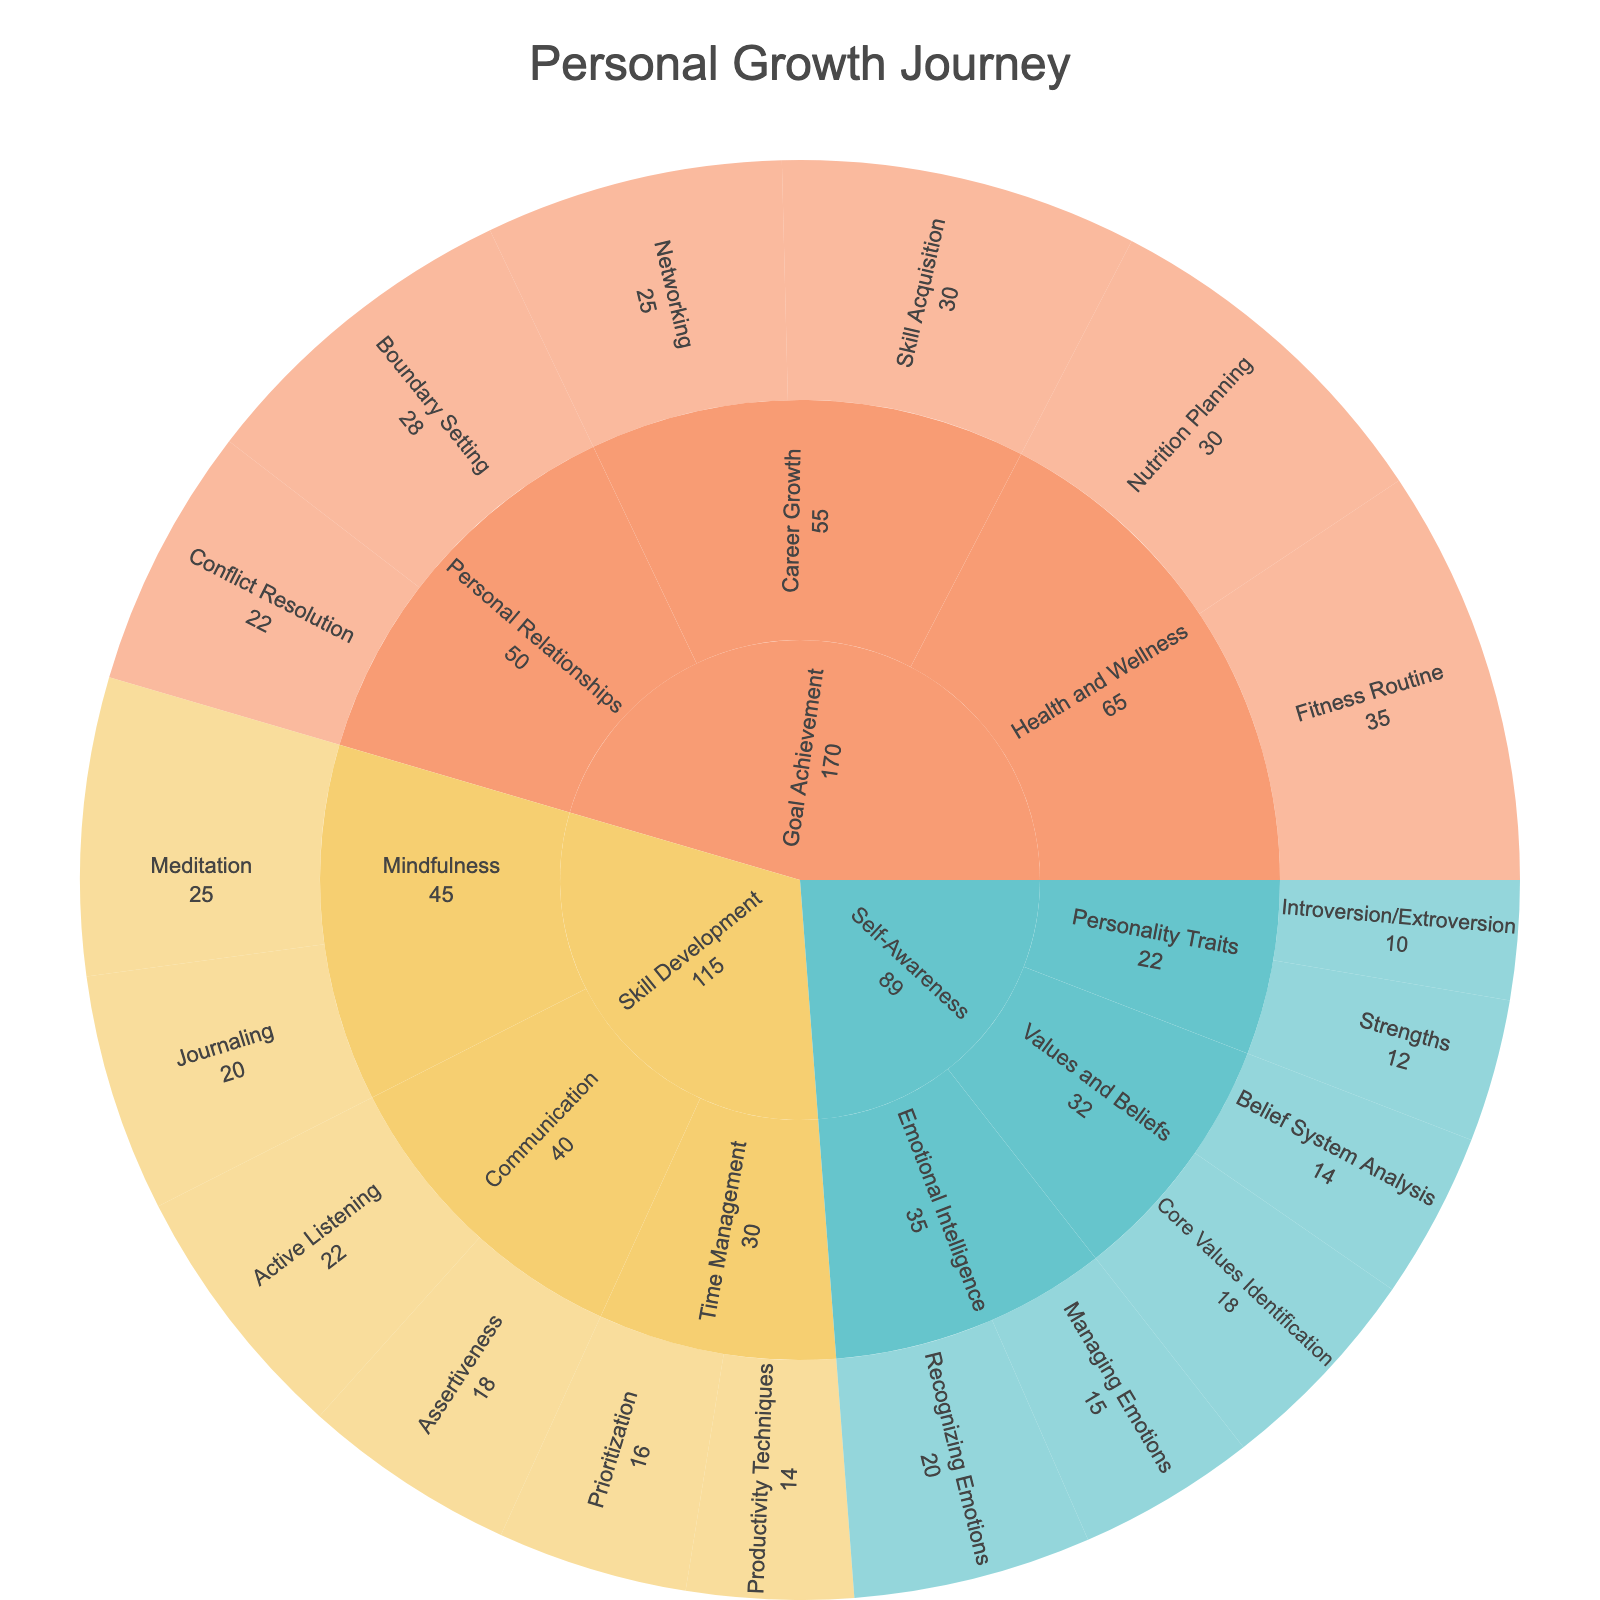How many subcategories are under the "Skill Development" stage? Count the subcategories under "Skill Development" in the figure: Active Listening, Assertiveness, Meditation, Journaling, Prioritization, Productivity Techniques. There are 6 subcategories.
Answer: 6 Which category has the highest total value in the "Goal Achievement" stage? Add the values of each subcategory under each category in the "Goal Achievement" stage. Career Growth: 30 + 25 = 55, Personal Relationships: 28 + 22 = 50, Health and Wellness: 35 + 30 = 65. Health and Wellness has the highest value of 65.
Answer: Health and Wellness What is the sum of all values in the "Self-Awareness" stage? Add the values of all subcategories in the "Self-Awareness" stage: 20 + 15 + 10 + 12 + 18 + 14 = 89.
Answer: 89 Compare the value of "Meditation" and "Recognizing Emotions". Which is higher? The value of "Meditation" is 25 and the value of "Recognizing Emotions" is 20. 25 is higher than 20.
Answer: Meditation What is the average value of the subcategories under "Emotional Intelligence" within the "Self-Awareness" stage? Add the values of the subcategories under "Emotional Intelligence": 20 + 15 = 35. Divide by the number of subcategories: 35 / 2 = 17.5.
Answer: 17.5 Which stage has the highest overall value? Calculate the sum of all values under each stage. Self-Awareness: 20 + 15 + 10 + 12 + 18 + 14 = 89, Skill Development: 22 + 18 + 25 + 20 + 16 + 14 = 115, Goal Achievement: 30 + 25 + 28 + 22 + 35 + 30 = 170. Goal Achievement has the highest overall value of 170.
Answer: Goal Achievement What is the difference in value between "Boundary Setting" and "Networking"? The value of "Boundary Setting" is 28 and the value of "Networking" is 25. Subtract 25 from 28 to get the difference: 28 - 25 = 3.
Answer: 3 Which subcategory has the lowest value among all three stages? Look at all subcategory values in the figure and find the smallest: Recognizing Emotions (20), Managing Emotions (15), Introversion/Extroversion (10), Strengths (12), Core Values Identification (18), Belief System Analysis (14), Active Listening (22), Assertiveness (18), Meditation (25), Journaling (20), Prioritization (16), Productivity Techniques (14), Skill Acquisition (30), Networking (25), Boundary Setting (28), Conflict Resolution (22), Fitness Routine (35), Nutrition Planning (30). Introversion/Extroversion has the lowest value of 10.
Answer: Introversion/Extroversion 